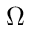Convert formula to latex. <formula><loc_0><loc_0><loc_500><loc_500>\Omega</formula> 